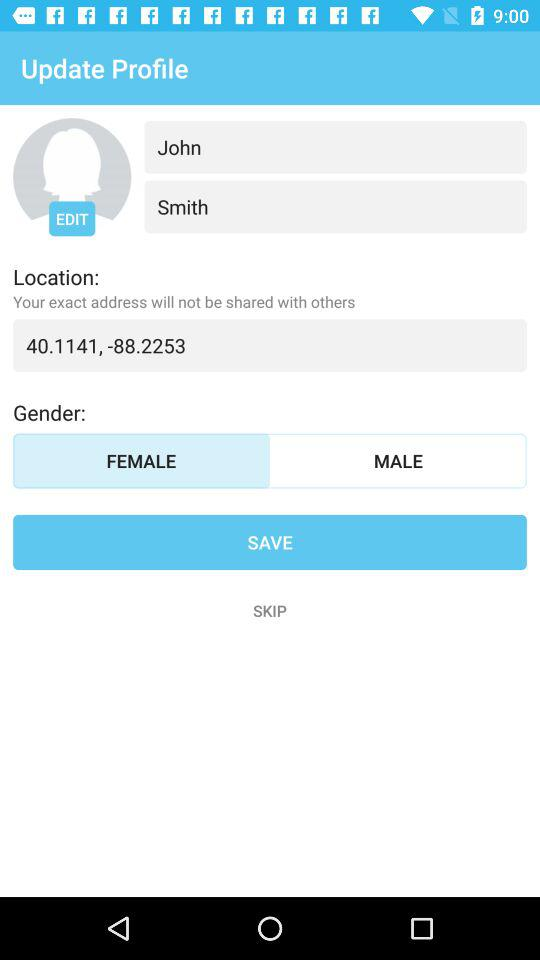Which option is selected for gender? The selected option for gender is "FEMALE". 